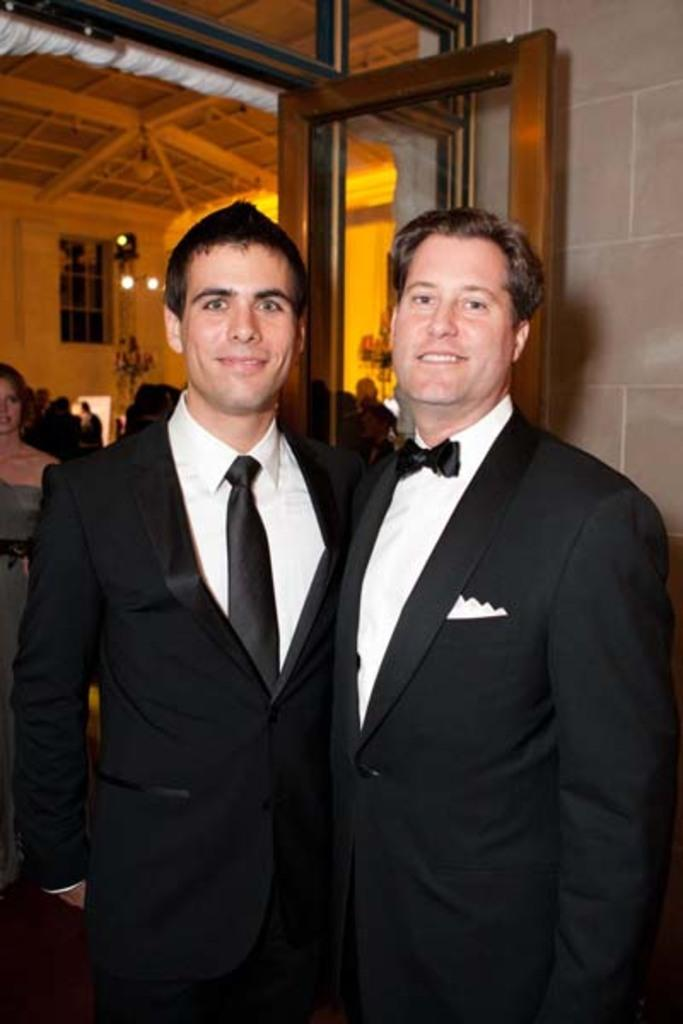What are the two people in the image doing? The two people in the image are taking a picture. Can you describe the surroundings of the two people? There are other people visible in the background, and there is a glass door in the background of the image. What type of shoes can be seen on the dock in the image? There is no dock or shoes present in the image. 